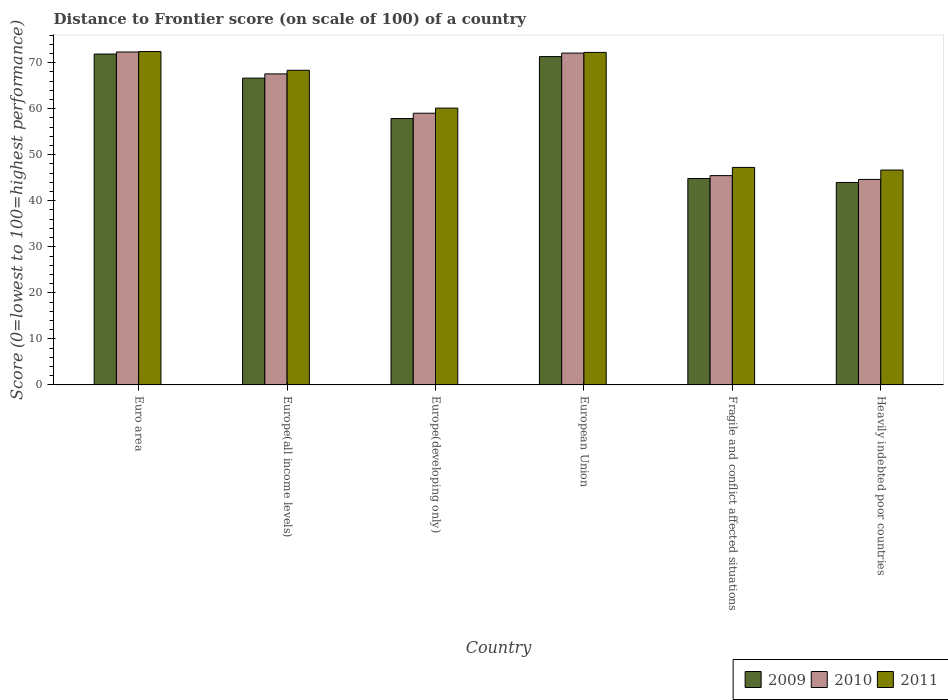How many different coloured bars are there?
Keep it short and to the point. 3. How many groups of bars are there?
Keep it short and to the point. 6. Are the number of bars per tick equal to the number of legend labels?
Your answer should be compact. Yes. Are the number of bars on each tick of the X-axis equal?
Your answer should be very brief. Yes. How many bars are there on the 5th tick from the left?
Offer a very short reply. 3. How many bars are there on the 5th tick from the right?
Provide a succinct answer. 3. What is the label of the 5th group of bars from the left?
Provide a short and direct response. Fragile and conflict affected situations. In how many cases, is the number of bars for a given country not equal to the number of legend labels?
Your answer should be very brief. 0. What is the distance to frontier score of in 2009 in European Union?
Offer a very short reply. 71.32. Across all countries, what is the maximum distance to frontier score of in 2010?
Make the answer very short. 72.32. Across all countries, what is the minimum distance to frontier score of in 2010?
Keep it short and to the point. 44.64. In which country was the distance to frontier score of in 2010 minimum?
Offer a very short reply. Heavily indebted poor countries. What is the total distance to frontier score of in 2010 in the graph?
Give a very brief answer. 361.07. What is the difference between the distance to frontier score of in 2011 in Europe(developing only) and that in European Union?
Ensure brevity in your answer.  -12.1. What is the difference between the distance to frontier score of in 2011 in Fragile and conflict affected situations and the distance to frontier score of in 2010 in Heavily indebted poor countries?
Give a very brief answer. 2.61. What is the average distance to frontier score of in 2011 per country?
Ensure brevity in your answer.  61.17. What is the difference between the distance to frontier score of of/in 2009 and distance to frontier score of of/in 2011 in Euro area?
Provide a short and direct response. -0.55. What is the ratio of the distance to frontier score of in 2011 in Europe(all income levels) to that in Europe(developing only)?
Give a very brief answer. 1.14. Is the distance to frontier score of in 2010 in Euro area less than that in European Union?
Your answer should be compact. No. What is the difference between the highest and the second highest distance to frontier score of in 2009?
Your answer should be very brief. -4.68. What is the difference between the highest and the lowest distance to frontier score of in 2010?
Your answer should be compact. 27.68. Is the sum of the distance to frontier score of in 2009 in Euro area and Heavily indebted poor countries greater than the maximum distance to frontier score of in 2011 across all countries?
Offer a very short reply. Yes. What does the 1st bar from the left in Fragile and conflict affected situations represents?
Give a very brief answer. 2009. What does the 1st bar from the right in European Union represents?
Your answer should be very brief. 2011. How many bars are there?
Offer a terse response. 18. Does the graph contain any zero values?
Your response must be concise. No. Does the graph contain grids?
Make the answer very short. No. How many legend labels are there?
Offer a very short reply. 3. How are the legend labels stacked?
Provide a short and direct response. Horizontal. What is the title of the graph?
Give a very brief answer. Distance to Frontier score (on scale of 100) of a country. Does "1984" appear as one of the legend labels in the graph?
Your answer should be compact. No. What is the label or title of the Y-axis?
Offer a terse response. Score (0=lowest to 100=highest performance). What is the Score (0=lowest to 100=highest performance) of 2009 in Euro area?
Your response must be concise. 71.87. What is the Score (0=lowest to 100=highest performance) in 2010 in Euro area?
Your response must be concise. 72.32. What is the Score (0=lowest to 100=highest performance) of 2011 in Euro area?
Your answer should be compact. 72.42. What is the Score (0=lowest to 100=highest performance) in 2009 in Europe(all income levels)?
Provide a short and direct response. 66.64. What is the Score (0=lowest to 100=highest performance) in 2010 in Europe(all income levels)?
Provide a succinct answer. 67.56. What is the Score (0=lowest to 100=highest performance) of 2011 in Europe(all income levels)?
Give a very brief answer. 68.35. What is the Score (0=lowest to 100=highest performance) of 2009 in Europe(developing only)?
Offer a very short reply. 57.86. What is the Score (0=lowest to 100=highest performance) in 2010 in Europe(developing only)?
Offer a very short reply. 59.02. What is the Score (0=lowest to 100=highest performance) in 2011 in Europe(developing only)?
Your response must be concise. 60.13. What is the Score (0=lowest to 100=highest performance) of 2009 in European Union?
Offer a very short reply. 71.32. What is the Score (0=lowest to 100=highest performance) of 2010 in European Union?
Give a very brief answer. 72.08. What is the Score (0=lowest to 100=highest performance) of 2011 in European Union?
Provide a short and direct response. 72.23. What is the Score (0=lowest to 100=highest performance) of 2009 in Fragile and conflict affected situations?
Your response must be concise. 44.84. What is the Score (0=lowest to 100=highest performance) of 2010 in Fragile and conflict affected situations?
Offer a very short reply. 45.46. What is the Score (0=lowest to 100=highest performance) in 2011 in Fragile and conflict affected situations?
Your answer should be very brief. 47.25. What is the Score (0=lowest to 100=highest performance) in 2009 in Heavily indebted poor countries?
Your response must be concise. 43.98. What is the Score (0=lowest to 100=highest performance) of 2010 in Heavily indebted poor countries?
Make the answer very short. 44.64. What is the Score (0=lowest to 100=highest performance) of 2011 in Heavily indebted poor countries?
Make the answer very short. 46.67. Across all countries, what is the maximum Score (0=lowest to 100=highest performance) in 2009?
Ensure brevity in your answer.  71.87. Across all countries, what is the maximum Score (0=lowest to 100=highest performance) in 2010?
Ensure brevity in your answer.  72.32. Across all countries, what is the maximum Score (0=lowest to 100=highest performance) of 2011?
Provide a succinct answer. 72.42. Across all countries, what is the minimum Score (0=lowest to 100=highest performance) in 2009?
Make the answer very short. 43.98. Across all countries, what is the minimum Score (0=lowest to 100=highest performance) of 2010?
Ensure brevity in your answer.  44.64. Across all countries, what is the minimum Score (0=lowest to 100=highest performance) in 2011?
Make the answer very short. 46.67. What is the total Score (0=lowest to 100=highest performance) of 2009 in the graph?
Your response must be concise. 356.5. What is the total Score (0=lowest to 100=highest performance) in 2010 in the graph?
Make the answer very short. 361.07. What is the total Score (0=lowest to 100=highest performance) of 2011 in the graph?
Your response must be concise. 367.04. What is the difference between the Score (0=lowest to 100=highest performance) of 2009 in Euro area and that in Europe(all income levels)?
Make the answer very short. 5.23. What is the difference between the Score (0=lowest to 100=highest performance) in 2010 in Euro area and that in Europe(all income levels)?
Make the answer very short. 4.76. What is the difference between the Score (0=lowest to 100=highest performance) of 2011 in Euro area and that in Europe(all income levels)?
Keep it short and to the point. 4.07. What is the difference between the Score (0=lowest to 100=highest performance) in 2009 in Euro area and that in Europe(developing only)?
Offer a very short reply. 14.01. What is the difference between the Score (0=lowest to 100=highest performance) in 2010 in Euro area and that in Europe(developing only)?
Make the answer very short. 13.3. What is the difference between the Score (0=lowest to 100=highest performance) of 2011 in Euro area and that in Europe(developing only)?
Give a very brief answer. 12.29. What is the difference between the Score (0=lowest to 100=highest performance) in 2009 in Euro area and that in European Union?
Provide a short and direct response. 0.55. What is the difference between the Score (0=lowest to 100=highest performance) of 2010 in Euro area and that in European Union?
Ensure brevity in your answer.  0.24. What is the difference between the Score (0=lowest to 100=highest performance) in 2011 in Euro area and that in European Union?
Give a very brief answer. 0.19. What is the difference between the Score (0=lowest to 100=highest performance) in 2009 in Euro area and that in Fragile and conflict affected situations?
Your answer should be very brief. 27.03. What is the difference between the Score (0=lowest to 100=highest performance) of 2010 in Euro area and that in Fragile and conflict affected situations?
Make the answer very short. 26.85. What is the difference between the Score (0=lowest to 100=highest performance) of 2011 in Euro area and that in Fragile and conflict affected situations?
Make the answer very short. 25.17. What is the difference between the Score (0=lowest to 100=highest performance) in 2009 in Euro area and that in Heavily indebted poor countries?
Offer a very short reply. 27.9. What is the difference between the Score (0=lowest to 100=highest performance) in 2010 in Euro area and that in Heavily indebted poor countries?
Provide a succinct answer. 27.68. What is the difference between the Score (0=lowest to 100=highest performance) in 2011 in Euro area and that in Heavily indebted poor countries?
Provide a succinct answer. 25.74. What is the difference between the Score (0=lowest to 100=highest performance) of 2009 in Europe(all income levels) and that in Europe(developing only)?
Provide a succinct answer. 8.78. What is the difference between the Score (0=lowest to 100=highest performance) in 2010 in Europe(all income levels) and that in Europe(developing only)?
Provide a short and direct response. 8.54. What is the difference between the Score (0=lowest to 100=highest performance) in 2011 in Europe(all income levels) and that in Europe(developing only)?
Provide a succinct answer. 8.22. What is the difference between the Score (0=lowest to 100=highest performance) of 2009 in Europe(all income levels) and that in European Union?
Provide a short and direct response. -4.68. What is the difference between the Score (0=lowest to 100=highest performance) in 2010 in Europe(all income levels) and that in European Union?
Give a very brief answer. -4.52. What is the difference between the Score (0=lowest to 100=highest performance) of 2011 in Europe(all income levels) and that in European Union?
Make the answer very short. -3.88. What is the difference between the Score (0=lowest to 100=highest performance) of 2009 in Europe(all income levels) and that in Fragile and conflict affected situations?
Provide a short and direct response. 21.8. What is the difference between the Score (0=lowest to 100=highest performance) of 2010 in Europe(all income levels) and that in Fragile and conflict affected situations?
Ensure brevity in your answer.  22.1. What is the difference between the Score (0=lowest to 100=highest performance) of 2011 in Europe(all income levels) and that in Fragile and conflict affected situations?
Your answer should be compact. 21.1. What is the difference between the Score (0=lowest to 100=highest performance) in 2009 in Europe(all income levels) and that in Heavily indebted poor countries?
Your answer should be compact. 22.67. What is the difference between the Score (0=lowest to 100=highest performance) of 2010 in Europe(all income levels) and that in Heavily indebted poor countries?
Make the answer very short. 22.92. What is the difference between the Score (0=lowest to 100=highest performance) of 2011 in Europe(all income levels) and that in Heavily indebted poor countries?
Provide a succinct answer. 21.68. What is the difference between the Score (0=lowest to 100=highest performance) of 2009 in Europe(developing only) and that in European Union?
Make the answer very short. -13.46. What is the difference between the Score (0=lowest to 100=highest performance) of 2010 in Europe(developing only) and that in European Union?
Make the answer very short. -13.06. What is the difference between the Score (0=lowest to 100=highest performance) in 2011 in Europe(developing only) and that in European Union?
Offer a very short reply. -12.1. What is the difference between the Score (0=lowest to 100=highest performance) in 2009 in Europe(developing only) and that in Fragile and conflict affected situations?
Make the answer very short. 13.02. What is the difference between the Score (0=lowest to 100=highest performance) in 2010 in Europe(developing only) and that in Fragile and conflict affected situations?
Offer a terse response. 13.55. What is the difference between the Score (0=lowest to 100=highest performance) in 2011 in Europe(developing only) and that in Fragile and conflict affected situations?
Your answer should be compact. 12.88. What is the difference between the Score (0=lowest to 100=highest performance) in 2009 in Europe(developing only) and that in Heavily indebted poor countries?
Give a very brief answer. 13.88. What is the difference between the Score (0=lowest to 100=highest performance) of 2010 in Europe(developing only) and that in Heavily indebted poor countries?
Offer a terse response. 14.38. What is the difference between the Score (0=lowest to 100=highest performance) in 2011 in Europe(developing only) and that in Heavily indebted poor countries?
Your response must be concise. 13.46. What is the difference between the Score (0=lowest to 100=highest performance) of 2009 in European Union and that in Fragile and conflict affected situations?
Your answer should be compact. 26.48. What is the difference between the Score (0=lowest to 100=highest performance) of 2010 in European Union and that in Fragile and conflict affected situations?
Provide a succinct answer. 26.61. What is the difference between the Score (0=lowest to 100=highest performance) in 2011 in European Union and that in Fragile and conflict affected situations?
Your response must be concise. 24.99. What is the difference between the Score (0=lowest to 100=highest performance) of 2009 in European Union and that in Heavily indebted poor countries?
Provide a short and direct response. 27.34. What is the difference between the Score (0=lowest to 100=highest performance) in 2010 in European Union and that in Heavily indebted poor countries?
Provide a short and direct response. 27.44. What is the difference between the Score (0=lowest to 100=highest performance) in 2011 in European Union and that in Heavily indebted poor countries?
Provide a short and direct response. 25.56. What is the difference between the Score (0=lowest to 100=highest performance) in 2009 in Fragile and conflict affected situations and that in Heavily indebted poor countries?
Give a very brief answer. 0.86. What is the difference between the Score (0=lowest to 100=highest performance) of 2010 in Fragile and conflict affected situations and that in Heavily indebted poor countries?
Offer a terse response. 0.83. What is the difference between the Score (0=lowest to 100=highest performance) of 2011 in Fragile and conflict affected situations and that in Heavily indebted poor countries?
Make the answer very short. 0.57. What is the difference between the Score (0=lowest to 100=highest performance) of 2009 in Euro area and the Score (0=lowest to 100=highest performance) of 2010 in Europe(all income levels)?
Provide a succinct answer. 4.31. What is the difference between the Score (0=lowest to 100=highest performance) of 2009 in Euro area and the Score (0=lowest to 100=highest performance) of 2011 in Europe(all income levels)?
Your answer should be compact. 3.52. What is the difference between the Score (0=lowest to 100=highest performance) in 2010 in Euro area and the Score (0=lowest to 100=highest performance) in 2011 in Europe(all income levels)?
Make the answer very short. 3.97. What is the difference between the Score (0=lowest to 100=highest performance) in 2009 in Euro area and the Score (0=lowest to 100=highest performance) in 2010 in Europe(developing only)?
Your response must be concise. 12.85. What is the difference between the Score (0=lowest to 100=highest performance) in 2009 in Euro area and the Score (0=lowest to 100=highest performance) in 2011 in Europe(developing only)?
Give a very brief answer. 11.74. What is the difference between the Score (0=lowest to 100=highest performance) in 2010 in Euro area and the Score (0=lowest to 100=highest performance) in 2011 in Europe(developing only)?
Ensure brevity in your answer.  12.19. What is the difference between the Score (0=lowest to 100=highest performance) of 2009 in Euro area and the Score (0=lowest to 100=highest performance) of 2010 in European Union?
Offer a terse response. -0.21. What is the difference between the Score (0=lowest to 100=highest performance) of 2009 in Euro area and the Score (0=lowest to 100=highest performance) of 2011 in European Union?
Provide a succinct answer. -0.36. What is the difference between the Score (0=lowest to 100=highest performance) of 2010 in Euro area and the Score (0=lowest to 100=highest performance) of 2011 in European Union?
Offer a terse response. 0.09. What is the difference between the Score (0=lowest to 100=highest performance) in 2009 in Euro area and the Score (0=lowest to 100=highest performance) in 2010 in Fragile and conflict affected situations?
Make the answer very short. 26.41. What is the difference between the Score (0=lowest to 100=highest performance) of 2009 in Euro area and the Score (0=lowest to 100=highest performance) of 2011 in Fragile and conflict affected situations?
Ensure brevity in your answer.  24.63. What is the difference between the Score (0=lowest to 100=highest performance) in 2010 in Euro area and the Score (0=lowest to 100=highest performance) in 2011 in Fragile and conflict affected situations?
Ensure brevity in your answer.  25.07. What is the difference between the Score (0=lowest to 100=highest performance) of 2009 in Euro area and the Score (0=lowest to 100=highest performance) of 2010 in Heavily indebted poor countries?
Provide a short and direct response. 27.24. What is the difference between the Score (0=lowest to 100=highest performance) in 2009 in Euro area and the Score (0=lowest to 100=highest performance) in 2011 in Heavily indebted poor countries?
Ensure brevity in your answer.  25.2. What is the difference between the Score (0=lowest to 100=highest performance) of 2010 in Euro area and the Score (0=lowest to 100=highest performance) of 2011 in Heavily indebted poor countries?
Keep it short and to the point. 25.65. What is the difference between the Score (0=lowest to 100=highest performance) of 2009 in Europe(all income levels) and the Score (0=lowest to 100=highest performance) of 2010 in Europe(developing only)?
Give a very brief answer. 7.62. What is the difference between the Score (0=lowest to 100=highest performance) of 2009 in Europe(all income levels) and the Score (0=lowest to 100=highest performance) of 2011 in Europe(developing only)?
Offer a very short reply. 6.51. What is the difference between the Score (0=lowest to 100=highest performance) of 2010 in Europe(all income levels) and the Score (0=lowest to 100=highest performance) of 2011 in Europe(developing only)?
Your answer should be very brief. 7.43. What is the difference between the Score (0=lowest to 100=highest performance) of 2009 in Europe(all income levels) and the Score (0=lowest to 100=highest performance) of 2010 in European Union?
Provide a short and direct response. -5.43. What is the difference between the Score (0=lowest to 100=highest performance) in 2009 in Europe(all income levels) and the Score (0=lowest to 100=highest performance) in 2011 in European Union?
Provide a succinct answer. -5.59. What is the difference between the Score (0=lowest to 100=highest performance) in 2010 in Europe(all income levels) and the Score (0=lowest to 100=highest performance) in 2011 in European Union?
Provide a short and direct response. -4.67. What is the difference between the Score (0=lowest to 100=highest performance) of 2009 in Europe(all income levels) and the Score (0=lowest to 100=highest performance) of 2010 in Fragile and conflict affected situations?
Your answer should be very brief. 21.18. What is the difference between the Score (0=lowest to 100=highest performance) of 2009 in Europe(all income levels) and the Score (0=lowest to 100=highest performance) of 2011 in Fragile and conflict affected situations?
Your answer should be very brief. 19.4. What is the difference between the Score (0=lowest to 100=highest performance) in 2010 in Europe(all income levels) and the Score (0=lowest to 100=highest performance) in 2011 in Fragile and conflict affected situations?
Your response must be concise. 20.31. What is the difference between the Score (0=lowest to 100=highest performance) of 2009 in Europe(all income levels) and the Score (0=lowest to 100=highest performance) of 2010 in Heavily indebted poor countries?
Make the answer very short. 22.01. What is the difference between the Score (0=lowest to 100=highest performance) of 2009 in Europe(all income levels) and the Score (0=lowest to 100=highest performance) of 2011 in Heavily indebted poor countries?
Provide a succinct answer. 19.97. What is the difference between the Score (0=lowest to 100=highest performance) in 2010 in Europe(all income levels) and the Score (0=lowest to 100=highest performance) in 2011 in Heavily indebted poor countries?
Your answer should be very brief. 20.89. What is the difference between the Score (0=lowest to 100=highest performance) of 2009 in Europe(developing only) and the Score (0=lowest to 100=highest performance) of 2010 in European Union?
Offer a terse response. -14.22. What is the difference between the Score (0=lowest to 100=highest performance) in 2009 in Europe(developing only) and the Score (0=lowest to 100=highest performance) in 2011 in European Union?
Keep it short and to the point. -14.37. What is the difference between the Score (0=lowest to 100=highest performance) of 2010 in Europe(developing only) and the Score (0=lowest to 100=highest performance) of 2011 in European Union?
Give a very brief answer. -13.21. What is the difference between the Score (0=lowest to 100=highest performance) of 2009 in Europe(developing only) and the Score (0=lowest to 100=highest performance) of 2010 in Fragile and conflict affected situations?
Make the answer very short. 12.39. What is the difference between the Score (0=lowest to 100=highest performance) of 2009 in Europe(developing only) and the Score (0=lowest to 100=highest performance) of 2011 in Fragile and conflict affected situations?
Provide a short and direct response. 10.61. What is the difference between the Score (0=lowest to 100=highest performance) in 2010 in Europe(developing only) and the Score (0=lowest to 100=highest performance) in 2011 in Fragile and conflict affected situations?
Offer a very short reply. 11.77. What is the difference between the Score (0=lowest to 100=highest performance) of 2009 in Europe(developing only) and the Score (0=lowest to 100=highest performance) of 2010 in Heavily indebted poor countries?
Your answer should be compact. 13.22. What is the difference between the Score (0=lowest to 100=highest performance) of 2009 in Europe(developing only) and the Score (0=lowest to 100=highest performance) of 2011 in Heavily indebted poor countries?
Offer a terse response. 11.18. What is the difference between the Score (0=lowest to 100=highest performance) of 2010 in Europe(developing only) and the Score (0=lowest to 100=highest performance) of 2011 in Heavily indebted poor countries?
Give a very brief answer. 12.35. What is the difference between the Score (0=lowest to 100=highest performance) in 2009 in European Union and the Score (0=lowest to 100=highest performance) in 2010 in Fragile and conflict affected situations?
Ensure brevity in your answer.  25.85. What is the difference between the Score (0=lowest to 100=highest performance) in 2009 in European Union and the Score (0=lowest to 100=highest performance) in 2011 in Fragile and conflict affected situations?
Ensure brevity in your answer.  24.07. What is the difference between the Score (0=lowest to 100=highest performance) in 2010 in European Union and the Score (0=lowest to 100=highest performance) in 2011 in Fragile and conflict affected situations?
Provide a short and direct response. 24.83. What is the difference between the Score (0=lowest to 100=highest performance) in 2009 in European Union and the Score (0=lowest to 100=highest performance) in 2010 in Heavily indebted poor countries?
Keep it short and to the point. 26.68. What is the difference between the Score (0=lowest to 100=highest performance) of 2009 in European Union and the Score (0=lowest to 100=highest performance) of 2011 in Heavily indebted poor countries?
Offer a very short reply. 24.65. What is the difference between the Score (0=lowest to 100=highest performance) of 2010 in European Union and the Score (0=lowest to 100=highest performance) of 2011 in Heavily indebted poor countries?
Provide a succinct answer. 25.4. What is the difference between the Score (0=lowest to 100=highest performance) of 2009 in Fragile and conflict affected situations and the Score (0=lowest to 100=highest performance) of 2010 in Heavily indebted poor countries?
Provide a short and direct response. 0.2. What is the difference between the Score (0=lowest to 100=highest performance) in 2009 in Fragile and conflict affected situations and the Score (0=lowest to 100=highest performance) in 2011 in Heavily indebted poor countries?
Offer a very short reply. -1.83. What is the difference between the Score (0=lowest to 100=highest performance) of 2010 in Fragile and conflict affected situations and the Score (0=lowest to 100=highest performance) of 2011 in Heavily indebted poor countries?
Provide a succinct answer. -1.21. What is the average Score (0=lowest to 100=highest performance) of 2009 per country?
Offer a terse response. 59.42. What is the average Score (0=lowest to 100=highest performance) of 2010 per country?
Make the answer very short. 60.18. What is the average Score (0=lowest to 100=highest performance) in 2011 per country?
Provide a short and direct response. 61.17. What is the difference between the Score (0=lowest to 100=highest performance) in 2009 and Score (0=lowest to 100=highest performance) in 2010 in Euro area?
Offer a very short reply. -0.45. What is the difference between the Score (0=lowest to 100=highest performance) of 2009 and Score (0=lowest to 100=highest performance) of 2011 in Euro area?
Keep it short and to the point. -0.55. What is the difference between the Score (0=lowest to 100=highest performance) of 2010 and Score (0=lowest to 100=highest performance) of 2011 in Euro area?
Provide a succinct answer. -0.1. What is the difference between the Score (0=lowest to 100=highest performance) in 2009 and Score (0=lowest to 100=highest performance) in 2010 in Europe(all income levels)?
Make the answer very short. -0.92. What is the difference between the Score (0=lowest to 100=highest performance) of 2009 and Score (0=lowest to 100=highest performance) of 2011 in Europe(all income levels)?
Give a very brief answer. -1.71. What is the difference between the Score (0=lowest to 100=highest performance) in 2010 and Score (0=lowest to 100=highest performance) in 2011 in Europe(all income levels)?
Provide a succinct answer. -0.79. What is the difference between the Score (0=lowest to 100=highest performance) of 2009 and Score (0=lowest to 100=highest performance) of 2010 in Europe(developing only)?
Your answer should be compact. -1.16. What is the difference between the Score (0=lowest to 100=highest performance) in 2009 and Score (0=lowest to 100=highest performance) in 2011 in Europe(developing only)?
Your answer should be very brief. -2.27. What is the difference between the Score (0=lowest to 100=highest performance) of 2010 and Score (0=lowest to 100=highest performance) of 2011 in Europe(developing only)?
Give a very brief answer. -1.11. What is the difference between the Score (0=lowest to 100=highest performance) of 2009 and Score (0=lowest to 100=highest performance) of 2010 in European Union?
Offer a very short reply. -0.76. What is the difference between the Score (0=lowest to 100=highest performance) in 2009 and Score (0=lowest to 100=highest performance) in 2011 in European Union?
Ensure brevity in your answer.  -0.91. What is the difference between the Score (0=lowest to 100=highest performance) of 2010 and Score (0=lowest to 100=highest performance) of 2011 in European Union?
Give a very brief answer. -0.15. What is the difference between the Score (0=lowest to 100=highest performance) of 2009 and Score (0=lowest to 100=highest performance) of 2010 in Fragile and conflict affected situations?
Ensure brevity in your answer.  -0.63. What is the difference between the Score (0=lowest to 100=highest performance) in 2009 and Score (0=lowest to 100=highest performance) in 2011 in Fragile and conflict affected situations?
Give a very brief answer. -2.41. What is the difference between the Score (0=lowest to 100=highest performance) of 2010 and Score (0=lowest to 100=highest performance) of 2011 in Fragile and conflict affected situations?
Offer a very short reply. -1.78. What is the difference between the Score (0=lowest to 100=highest performance) in 2009 and Score (0=lowest to 100=highest performance) in 2010 in Heavily indebted poor countries?
Ensure brevity in your answer.  -0.66. What is the difference between the Score (0=lowest to 100=highest performance) of 2009 and Score (0=lowest to 100=highest performance) of 2011 in Heavily indebted poor countries?
Give a very brief answer. -2.7. What is the difference between the Score (0=lowest to 100=highest performance) of 2010 and Score (0=lowest to 100=highest performance) of 2011 in Heavily indebted poor countries?
Offer a terse response. -2.04. What is the ratio of the Score (0=lowest to 100=highest performance) of 2009 in Euro area to that in Europe(all income levels)?
Give a very brief answer. 1.08. What is the ratio of the Score (0=lowest to 100=highest performance) of 2010 in Euro area to that in Europe(all income levels)?
Give a very brief answer. 1.07. What is the ratio of the Score (0=lowest to 100=highest performance) of 2011 in Euro area to that in Europe(all income levels)?
Your answer should be compact. 1.06. What is the ratio of the Score (0=lowest to 100=highest performance) in 2009 in Euro area to that in Europe(developing only)?
Provide a short and direct response. 1.24. What is the ratio of the Score (0=lowest to 100=highest performance) in 2010 in Euro area to that in Europe(developing only)?
Make the answer very short. 1.23. What is the ratio of the Score (0=lowest to 100=highest performance) in 2011 in Euro area to that in Europe(developing only)?
Make the answer very short. 1.2. What is the ratio of the Score (0=lowest to 100=highest performance) of 2011 in Euro area to that in European Union?
Make the answer very short. 1. What is the ratio of the Score (0=lowest to 100=highest performance) of 2009 in Euro area to that in Fragile and conflict affected situations?
Make the answer very short. 1.6. What is the ratio of the Score (0=lowest to 100=highest performance) in 2010 in Euro area to that in Fragile and conflict affected situations?
Ensure brevity in your answer.  1.59. What is the ratio of the Score (0=lowest to 100=highest performance) in 2011 in Euro area to that in Fragile and conflict affected situations?
Offer a very short reply. 1.53. What is the ratio of the Score (0=lowest to 100=highest performance) of 2009 in Euro area to that in Heavily indebted poor countries?
Offer a terse response. 1.63. What is the ratio of the Score (0=lowest to 100=highest performance) in 2010 in Euro area to that in Heavily indebted poor countries?
Make the answer very short. 1.62. What is the ratio of the Score (0=lowest to 100=highest performance) in 2011 in Euro area to that in Heavily indebted poor countries?
Offer a very short reply. 1.55. What is the ratio of the Score (0=lowest to 100=highest performance) in 2009 in Europe(all income levels) to that in Europe(developing only)?
Provide a short and direct response. 1.15. What is the ratio of the Score (0=lowest to 100=highest performance) of 2010 in Europe(all income levels) to that in Europe(developing only)?
Keep it short and to the point. 1.14. What is the ratio of the Score (0=lowest to 100=highest performance) in 2011 in Europe(all income levels) to that in Europe(developing only)?
Your answer should be compact. 1.14. What is the ratio of the Score (0=lowest to 100=highest performance) of 2009 in Europe(all income levels) to that in European Union?
Your answer should be compact. 0.93. What is the ratio of the Score (0=lowest to 100=highest performance) in 2010 in Europe(all income levels) to that in European Union?
Give a very brief answer. 0.94. What is the ratio of the Score (0=lowest to 100=highest performance) in 2011 in Europe(all income levels) to that in European Union?
Provide a short and direct response. 0.95. What is the ratio of the Score (0=lowest to 100=highest performance) in 2009 in Europe(all income levels) to that in Fragile and conflict affected situations?
Your answer should be very brief. 1.49. What is the ratio of the Score (0=lowest to 100=highest performance) of 2010 in Europe(all income levels) to that in Fragile and conflict affected situations?
Your answer should be very brief. 1.49. What is the ratio of the Score (0=lowest to 100=highest performance) of 2011 in Europe(all income levels) to that in Fragile and conflict affected situations?
Your answer should be very brief. 1.45. What is the ratio of the Score (0=lowest to 100=highest performance) of 2009 in Europe(all income levels) to that in Heavily indebted poor countries?
Ensure brevity in your answer.  1.52. What is the ratio of the Score (0=lowest to 100=highest performance) in 2010 in Europe(all income levels) to that in Heavily indebted poor countries?
Your answer should be compact. 1.51. What is the ratio of the Score (0=lowest to 100=highest performance) in 2011 in Europe(all income levels) to that in Heavily indebted poor countries?
Make the answer very short. 1.46. What is the ratio of the Score (0=lowest to 100=highest performance) of 2009 in Europe(developing only) to that in European Union?
Offer a very short reply. 0.81. What is the ratio of the Score (0=lowest to 100=highest performance) of 2010 in Europe(developing only) to that in European Union?
Your answer should be compact. 0.82. What is the ratio of the Score (0=lowest to 100=highest performance) of 2011 in Europe(developing only) to that in European Union?
Ensure brevity in your answer.  0.83. What is the ratio of the Score (0=lowest to 100=highest performance) in 2009 in Europe(developing only) to that in Fragile and conflict affected situations?
Make the answer very short. 1.29. What is the ratio of the Score (0=lowest to 100=highest performance) in 2010 in Europe(developing only) to that in Fragile and conflict affected situations?
Ensure brevity in your answer.  1.3. What is the ratio of the Score (0=lowest to 100=highest performance) in 2011 in Europe(developing only) to that in Fragile and conflict affected situations?
Your answer should be very brief. 1.27. What is the ratio of the Score (0=lowest to 100=highest performance) of 2009 in Europe(developing only) to that in Heavily indebted poor countries?
Offer a very short reply. 1.32. What is the ratio of the Score (0=lowest to 100=highest performance) of 2010 in Europe(developing only) to that in Heavily indebted poor countries?
Your response must be concise. 1.32. What is the ratio of the Score (0=lowest to 100=highest performance) in 2011 in Europe(developing only) to that in Heavily indebted poor countries?
Provide a short and direct response. 1.29. What is the ratio of the Score (0=lowest to 100=highest performance) in 2009 in European Union to that in Fragile and conflict affected situations?
Provide a short and direct response. 1.59. What is the ratio of the Score (0=lowest to 100=highest performance) of 2010 in European Union to that in Fragile and conflict affected situations?
Make the answer very short. 1.59. What is the ratio of the Score (0=lowest to 100=highest performance) in 2011 in European Union to that in Fragile and conflict affected situations?
Give a very brief answer. 1.53. What is the ratio of the Score (0=lowest to 100=highest performance) in 2009 in European Union to that in Heavily indebted poor countries?
Offer a very short reply. 1.62. What is the ratio of the Score (0=lowest to 100=highest performance) in 2010 in European Union to that in Heavily indebted poor countries?
Your answer should be very brief. 1.61. What is the ratio of the Score (0=lowest to 100=highest performance) in 2011 in European Union to that in Heavily indebted poor countries?
Offer a terse response. 1.55. What is the ratio of the Score (0=lowest to 100=highest performance) in 2009 in Fragile and conflict affected situations to that in Heavily indebted poor countries?
Make the answer very short. 1.02. What is the ratio of the Score (0=lowest to 100=highest performance) of 2010 in Fragile and conflict affected situations to that in Heavily indebted poor countries?
Keep it short and to the point. 1.02. What is the ratio of the Score (0=lowest to 100=highest performance) in 2011 in Fragile and conflict affected situations to that in Heavily indebted poor countries?
Offer a terse response. 1.01. What is the difference between the highest and the second highest Score (0=lowest to 100=highest performance) of 2009?
Offer a terse response. 0.55. What is the difference between the highest and the second highest Score (0=lowest to 100=highest performance) in 2010?
Your answer should be very brief. 0.24. What is the difference between the highest and the second highest Score (0=lowest to 100=highest performance) of 2011?
Provide a succinct answer. 0.19. What is the difference between the highest and the lowest Score (0=lowest to 100=highest performance) in 2009?
Your response must be concise. 27.9. What is the difference between the highest and the lowest Score (0=lowest to 100=highest performance) of 2010?
Offer a terse response. 27.68. What is the difference between the highest and the lowest Score (0=lowest to 100=highest performance) in 2011?
Ensure brevity in your answer.  25.74. 